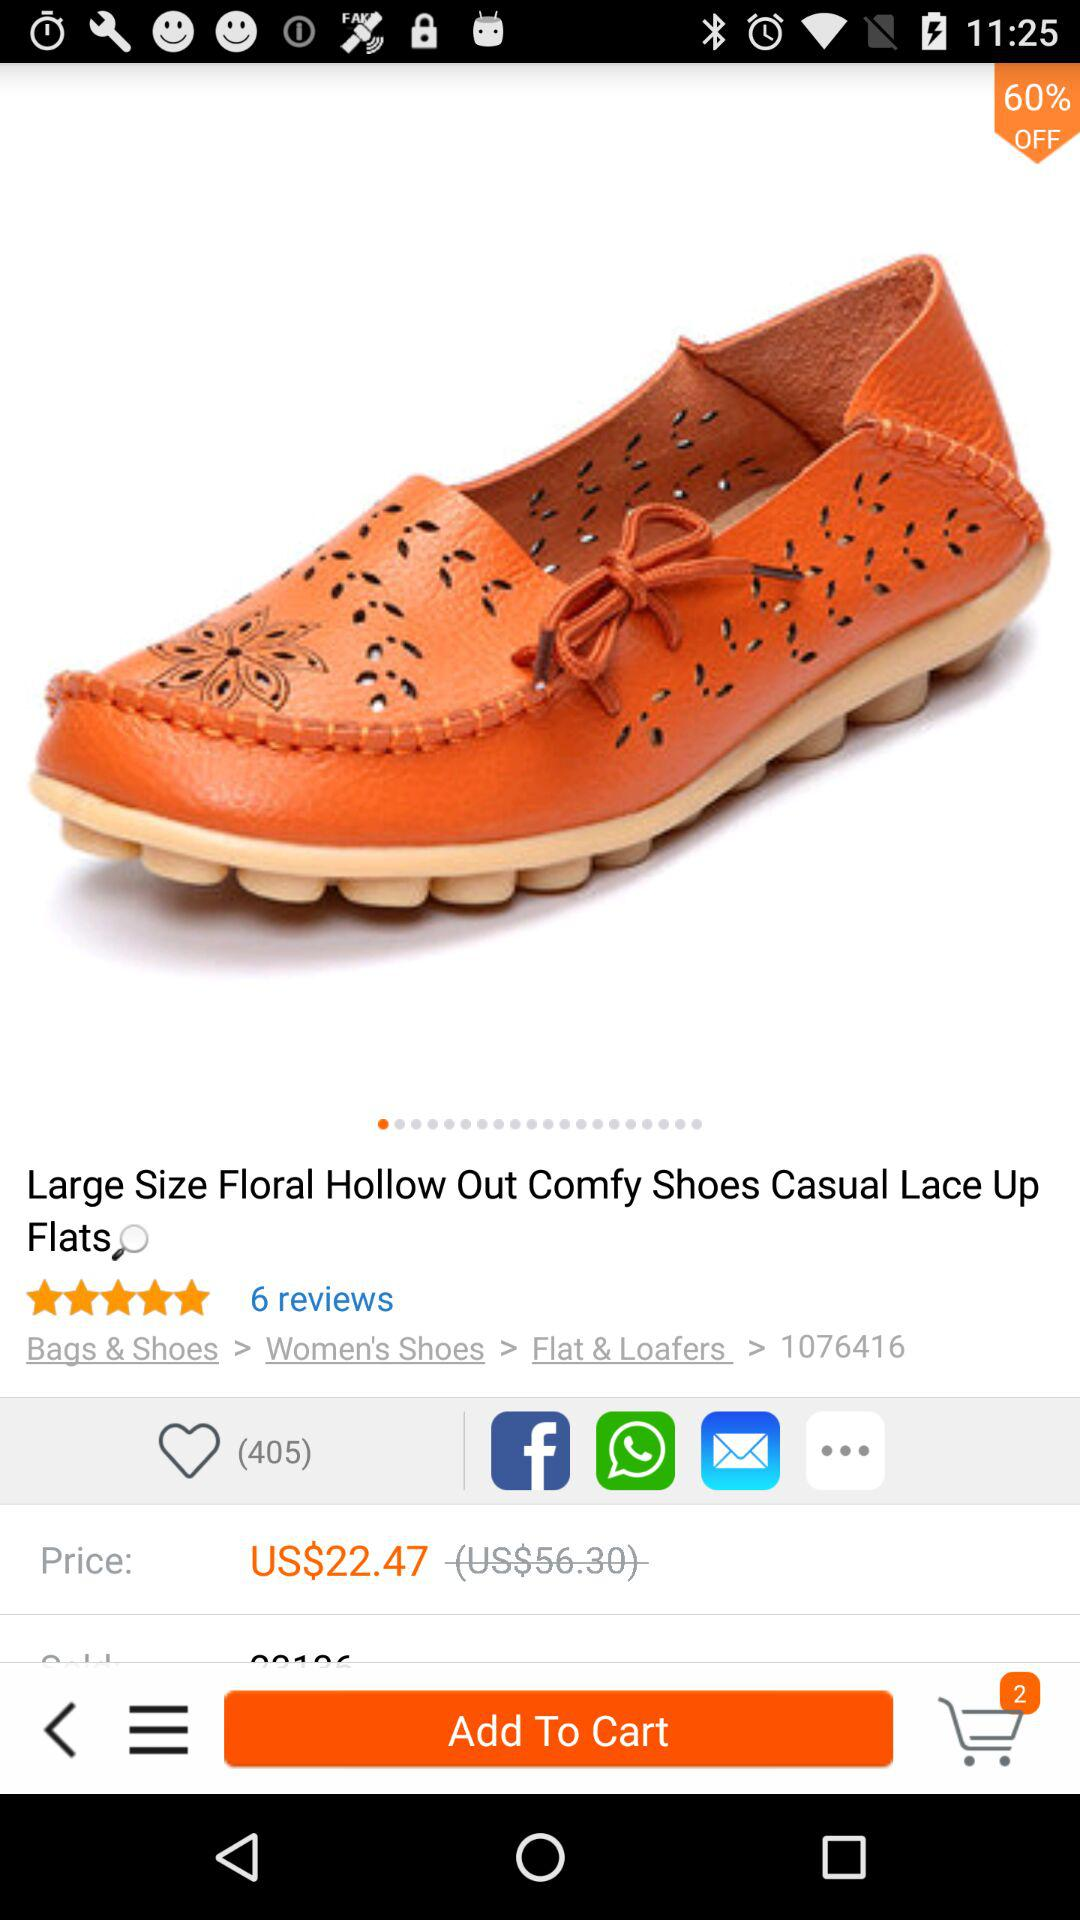What is the price of casual lace-up flats? The price is US$22.47. 